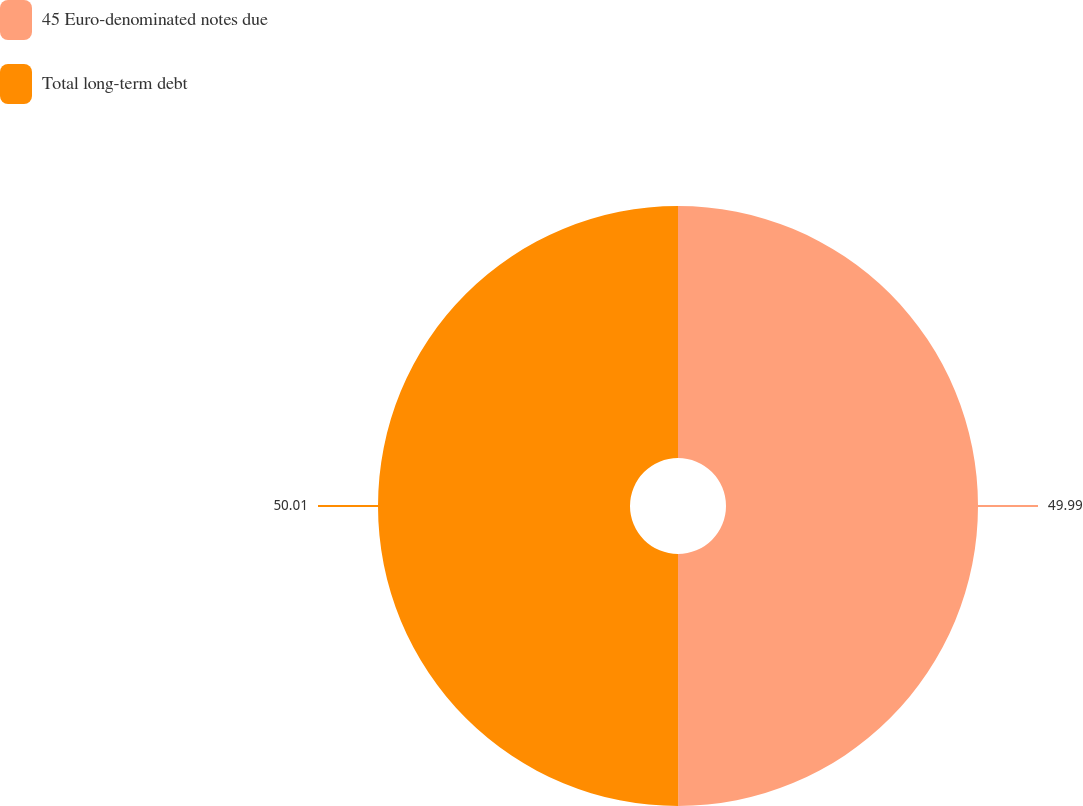Convert chart to OTSL. <chart><loc_0><loc_0><loc_500><loc_500><pie_chart><fcel>45 Euro-denominated notes due<fcel>Total long-term debt<nl><fcel>49.99%<fcel>50.01%<nl></chart> 